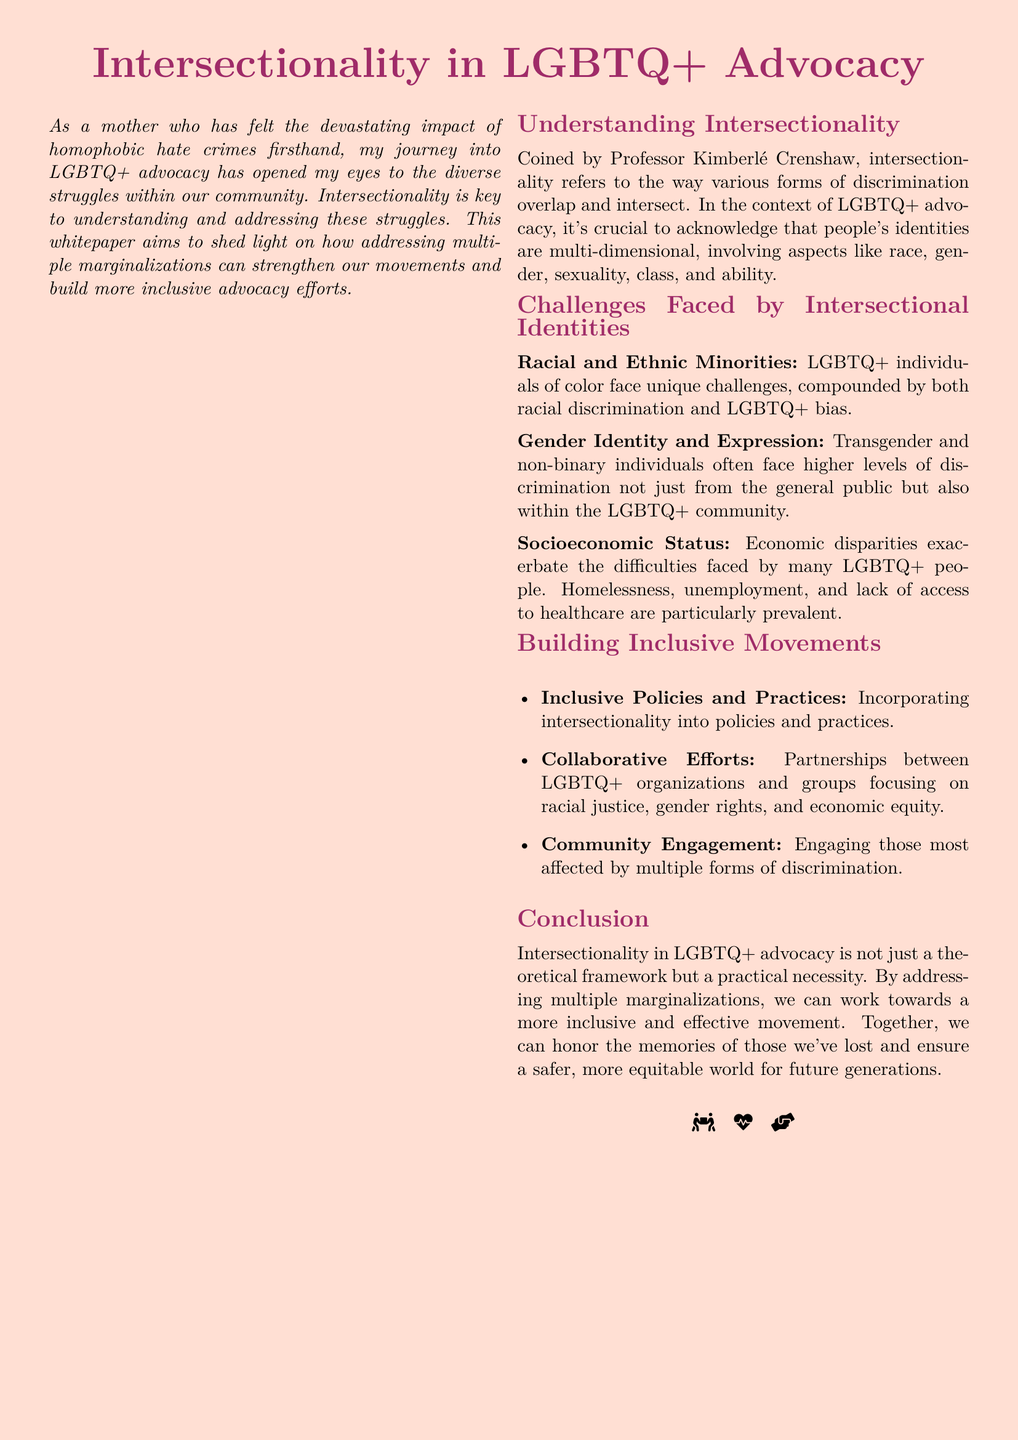what term was coined by Professor Kimberlé Crenshaw? The document states that "intersectionality" refers to the way various forms of discrimination overlap and intersect.
Answer: intersectionality what unique challenges do LGBTQ+ individuals of color face? The document mentions challenges faced by racial and ethnic minorities, noting they encounter "racial discrimination and LGBTQ+ bias."
Answer: racial discrimination and LGBTQ+ bias which identities often face higher levels of discrimination, according to the document? The document highlights that "Transgender and non-binary individuals" experience greater discrimination.
Answer: Transgender and non-binary individuals what is a key action for building inclusive movements? The document lists "Incorporating intersectionality into policies and practices" as a vital action.
Answer: Incorporating intersectionality into policies and practices what are the three focuses of collaborative efforts suggested in the advocacy? The document notes the need for partnerships focusing on "racial justice, gender rights, and economic equity."
Answer: racial justice, gender rights, and economic equity how does the paper describe the nature of intersectionality in LGBTQ+ advocacy? The conclusion notes that intersectionality is not merely theoretical but a "practical necessity."
Answer: practical necessity what is the overall goal of addressing multiple marginalizations in LGBTQ+ advocacy? The document outlines the aim of working towards a "more inclusive and effective movement."
Answer: more inclusive and effective movement what symbol is used at the end of the document? The document includes icons representing community support and health engagement.
Answer: community support and health engagement who authored the whitepaper? The introduction mentions the author's experiences related to LGBTQ+ advocacy and personal loss.
Answer: a mother who lost her child what color is used for the document's background? The document specifies that the background is a light shade, which is described as "secondcolor."
Answer: secondcolor 